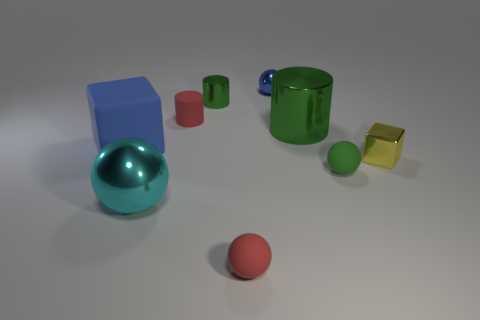How many objects in the image are touching each other? From the perspective provided, it appears that none of the objects in the image are directly touching each other. Each object sits independently on the surface, surrounded by a clear amount of space, ensuring that they are distinguishable from one another. 